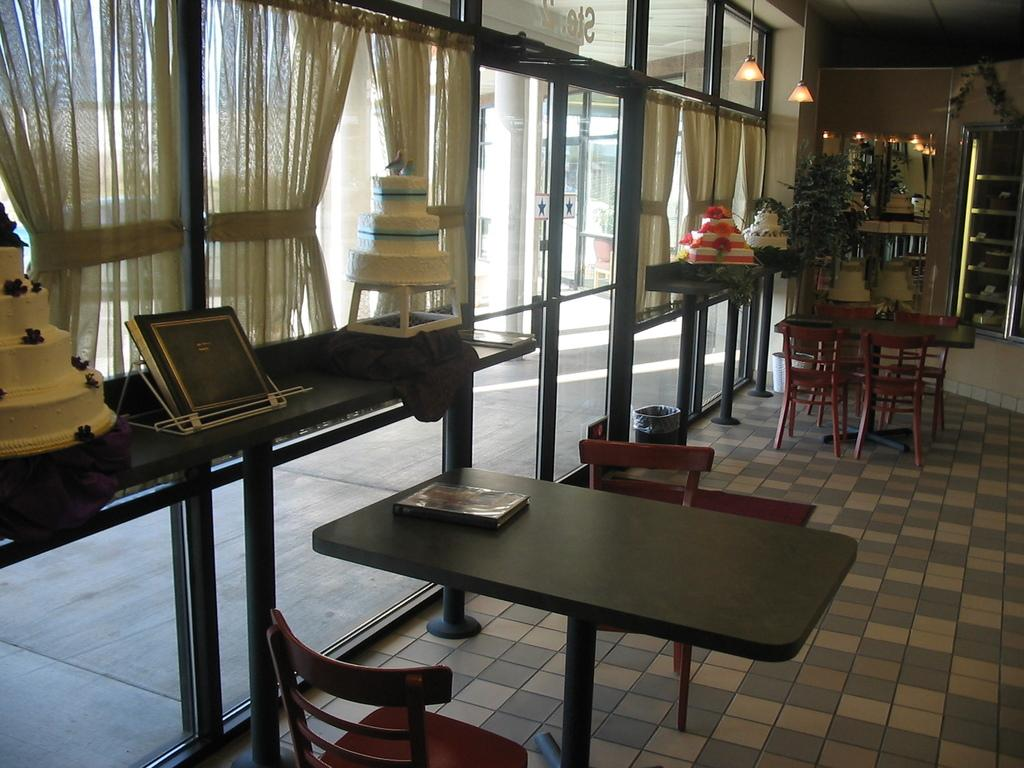What type of furniture can be seen in the image? There are tables and chairs in the image. What is visible on the floor in the image? The floor is visible in the image. What type of food is present in the image? There are cakes in the image. What type of window treatment is present in the image? There are curtains in the image. What type of tableware is present in the image? There are glasses in the image. What type of lighting is present in the image? There are lights in the image. What type of greenery is present in the image? There are plants in the image. What type of waste disposal is present in the image? There is a bin in the image. What type of architectural feature is present in the image? There are pillars in the image. What type of wall is present in the image? There is a wall in the image. What type of reading material is present in the image? There is a book in the image. What other objects can be seen in the image? There are other objects in the image. What type of chain is visible in the image? There is no chain present in the image. What type of engine is visible in the image? There is no engine present in the image. What type of kettle is visible in the image? There is no kettle present in the image. 